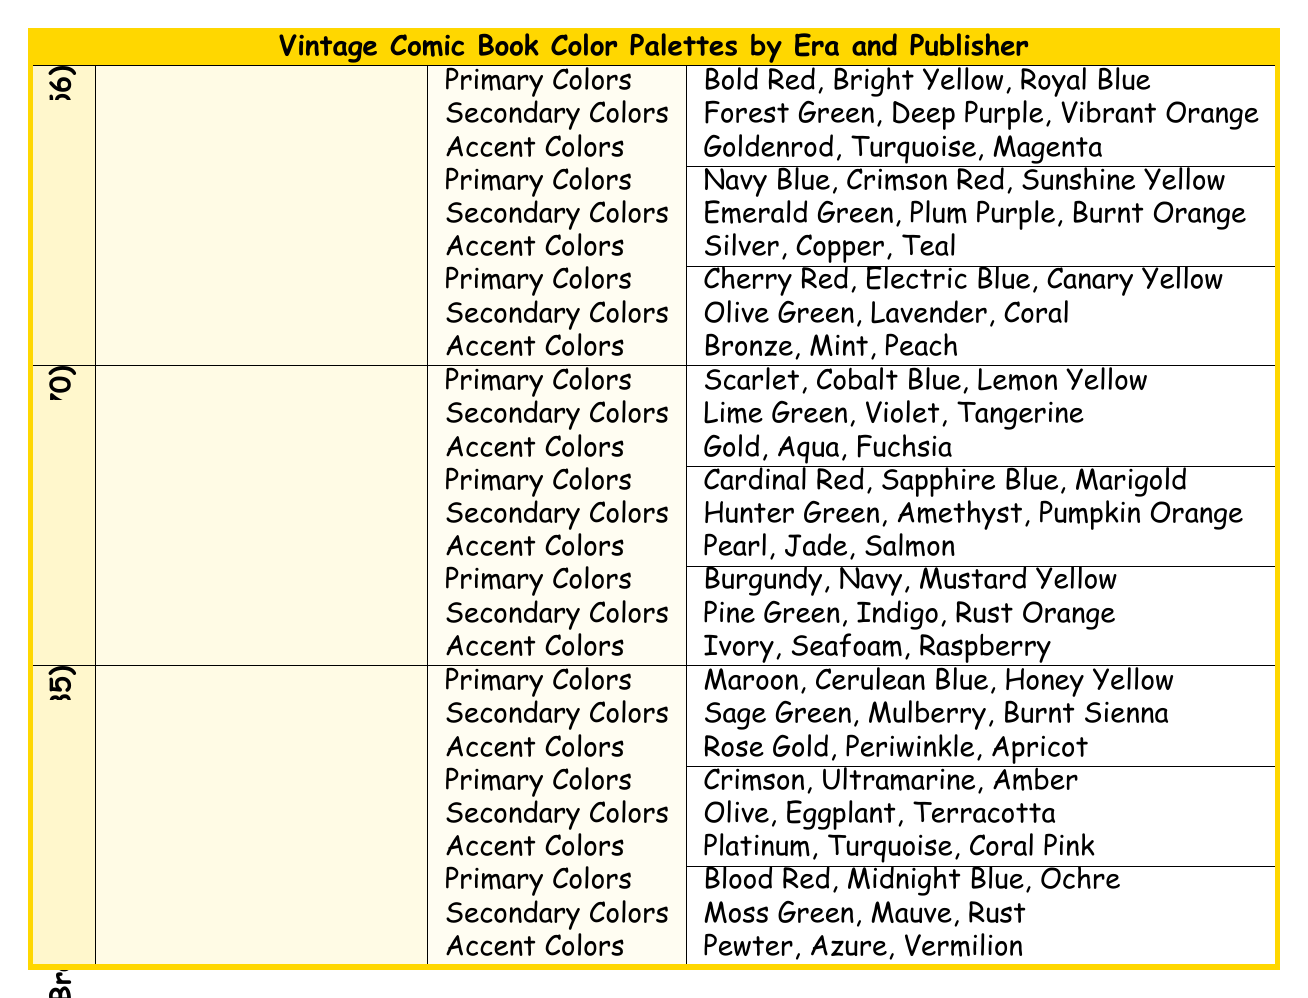What are the primary colors used by DC Comics in the Golden Age? The table lists the primary colors used by DC Comics in the Golden Age (1938-1956), which are Bold Red, Bright Yellow, and Royal Blue.
Answer: Bold Red, Bright Yellow, Royal Blue Which publisher used the color Burgundy as a primary color during the Silver Age? By examining the Silver Age (1956-1970) section, we see that Burgundy is listed as a primary color for Charlton Comics.
Answer: Charlton Comics Is there a publisher that used the color Coral in the Bronze Age? The table shows that DC Comics uses Coral Pink as an accent color and Warren Publishing uses Coral as a secondary color in the Bronze Age. Therefore, at least one publisher used Coral.
Answer: Yes Which era had the highest number of unique accent colors listed in the provided table? I will compare the total number of accent colors from each era. The Golden Age has 9, the Silver Age has 9, and the Bronze Age has 9. Each era has an equal number of accent colors.
Answer: All eras have the same number of accent colors What is the average number of primary colors used by publishers during the Golden Age? There are three publishers in the Golden Age (DC Comics, Timely Comics, and Fawcett Comics), each with three primary colors. To find the average, we sum the primary colors (3+3+3=9) and divide by the number of publishers (9/3=3). The average is 3 primary colors.
Answer: 3 List the accent colors used by Marvel Comics in the Silver Age. In the Silver Age (1956-1970), Marvel Comics has three accent colors: Gold, Aqua, and Fuchsia, as mentioned in the table.
Answer: Gold, Aqua, Fuchsia Which publisher incorporated the color Teal as an accent color in the Golden Age? Looking at the Golden Age section, Timely Comics (Marvel) lists Teal as one of its accent colors.
Answer: Timely Comics (Marvel) How many secondary colors does Fawcett Comics use in the Golden Age? The secondary colors for Fawcett Comics in the Golden Age are Olive Green, Lavender, and Coral. There are three colors listed, thus Fawcett Comics uses three secondary colors.
Answer: 3 If we compare the primary colors of DC Comics across all eras, which era has the most distinct primary color? By checking the primary colors from DC Comics in each era, we find: Golden Age has 3 (Bold Red, Bright Yellow, Royal Blue), Silver Age has 3 (Cardinal Red, Sapphire Blue, Marigold), and Bronze Age has 3 (Crimson, Ultramarine, Amber). All eras have the same number of distinct primary colors; none has more than 3.
Answer: None Which accent color is common to both DC Comics in the Bronze Age and Warren Publishing? Looking at the tables, it's observed that both DC Comics in the Bronze Age and Warren Publishing use the accent color Turquoise, making it common between them.
Answer: Turquoise 